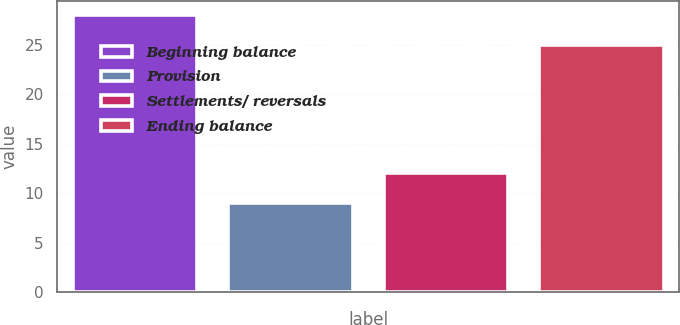<chart> <loc_0><loc_0><loc_500><loc_500><bar_chart><fcel>Beginning balance<fcel>Provision<fcel>Settlements/ reversals<fcel>Ending balance<nl><fcel>28<fcel>9<fcel>12<fcel>25<nl></chart> 